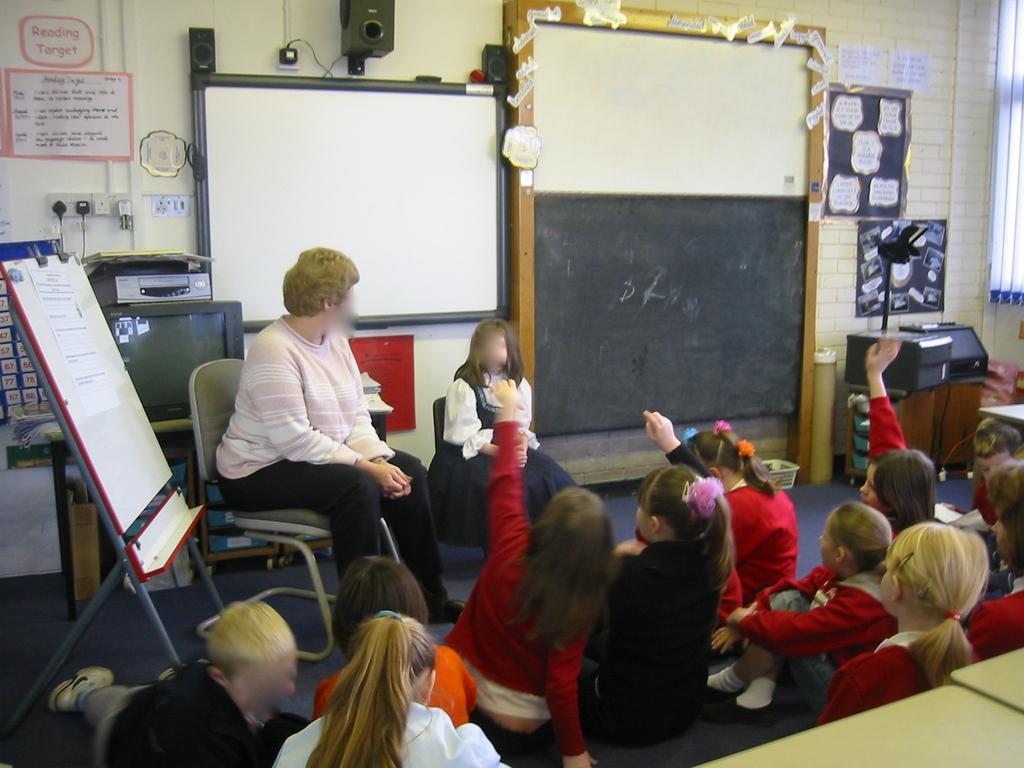Please provide a concise description of this image. Few persons sitting on the floor and these two persons sitting on the chair. We can see board with stand,white board,floor,wall,posters. 